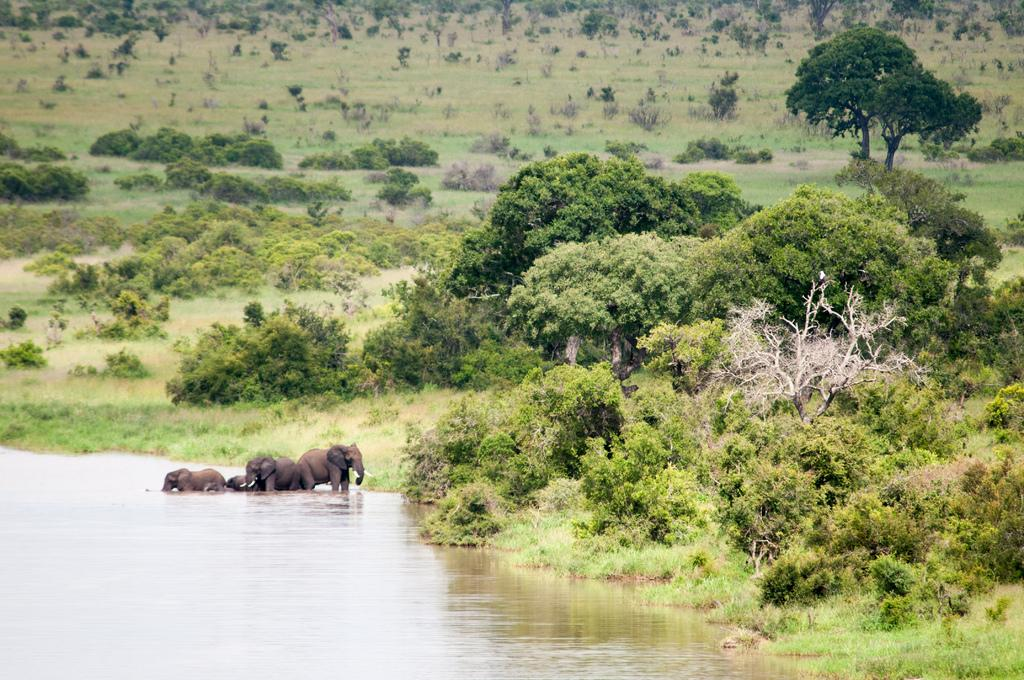What animals are present in the image? There are elephants in the image. Where are the elephants located? The elephants are in the water. What type of vegetation can be seen in the image? There are trees visible in the image. What year is depicted in the image? The provided facts do not mention any specific year, and there is no indication of a particular time period in the image. 